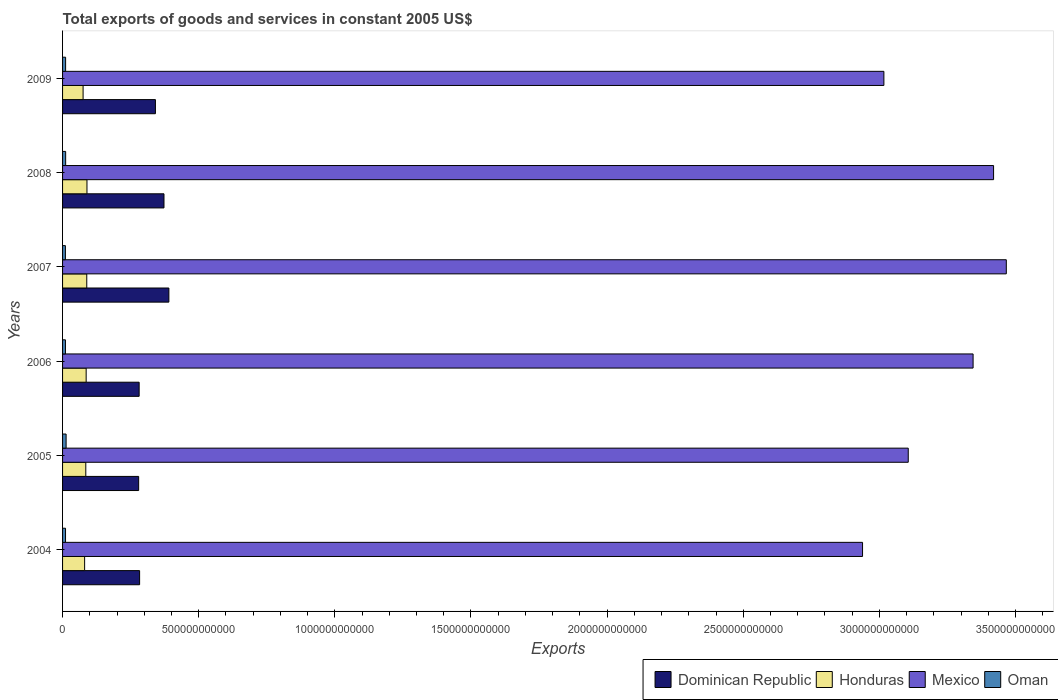Are the number of bars per tick equal to the number of legend labels?
Your answer should be compact. Yes. Are the number of bars on each tick of the Y-axis equal?
Provide a succinct answer. Yes. How many bars are there on the 4th tick from the top?
Make the answer very short. 4. In how many cases, is the number of bars for a given year not equal to the number of legend labels?
Ensure brevity in your answer.  0. What is the total exports of goods and services in Mexico in 2004?
Offer a terse response. 2.94e+12. Across all years, what is the maximum total exports of goods and services in Oman?
Your response must be concise. 1.30e+1. Across all years, what is the minimum total exports of goods and services in Mexico?
Your answer should be very brief. 2.94e+12. What is the total total exports of goods and services in Honduras in the graph?
Your response must be concise. 5.07e+11. What is the difference between the total exports of goods and services in Oman in 2005 and that in 2008?
Provide a succinct answer. 1.68e+09. What is the difference between the total exports of goods and services in Dominican Republic in 2005 and the total exports of goods and services in Oman in 2009?
Provide a succinct answer. 2.68e+11. What is the average total exports of goods and services in Oman per year?
Provide a short and direct response. 1.13e+1. In the year 2005, what is the difference between the total exports of goods and services in Oman and total exports of goods and services in Dominican Republic?
Your answer should be very brief. -2.66e+11. What is the ratio of the total exports of goods and services in Mexico in 2004 to that in 2009?
Provide a succinct answer. 0.97. Is the difference between the total exports of goods and services in Oman in 2004 and 2007 greater than the difference between the total exports of goods and services in Dominican Republic in 2004 and 2007?
Keep it short and to the point. Yes. What is the difference between the highest and the second highest total exports of goods and services in Honduras?
Offer a very short reply. 7.64e+08. What is the difference between the highest and the lowest total exports of goods and services in Honduras?
Provide a short and direct response. 1.42e+1. What does the 1st bar from the top in 2004 represents?
Make the answer very short. Oman. What does the 1st bar from the bottom in 2006 represents?
Your answer should be very brief. Dominican Republic. Is it the case that in every year, the sum of the total exports of goods and services in Oman and total exports of goods and services in Dominican Republic is greater than the total exports of goods and services in Honduras?
Offer a terse response. Yes. How many bars are there?
Make the answer very short. 24. How many years are there in the graph?
Offer a terse response. 6. What is the difference between two consecutive major ticks on the X-axis?
Ensure brevity in your answer.  5.00e+11. Are the values on the major ticks of X-axis written in scientific E-notation?
Give a very brief answer. No. How many legend labels are there?
Offer a terse response. 4. How are the legend labels stacked?
Make the answer very short. Horizontal. What is the title of the graph?
Provide a succinct answer. Total exports of goods and services in constant 2005 US$. Does "Moldova" appear as one of the legend labels in the graph?
Your answer should be compact. No. What is the label or title of the X-axis?
Your response must be concise. Exports. What is the label or title of the Y-axis?
Offer a terse response. Years. What is the Exports in Dominican Republic in 2004?
Your answer should be compact. 2.83e+11. What is the Exports in Honduras in 2004?
Ensure brevity in your answer.  8.10e+1. What is the Exports of Mexico in 2004?
Provide a succinct answer. 2.94e+12. What is the Exports of Oman in 2004?
Offer a terse response. 1.09e+1. What is the Exports in Dominican Republic in 2005?
Your answer should be compact. 2.79e+11. What is the Exports of Honduras in 2005?
Provide a short and direct response. 8.53e+1. What is the Exports in Mexico in 2005?
Your answer should be very brief. 3.11e+12. What is the Exports of Oman in 2005?
Give a very brief answer. 1.30e+1. What is the Exports of Dominican Republic in 2006?
Make the answer very short. 2.81e+11. What is the Exports of Honduras in 2006?
Ensure brevity in your answer.  8.67e+1. What is the Exports of Mexico in 2006?
Your response must be concise. 3.34e+12. What is the Exports of Oman in 2006?
Provide a short and direct response. 1.06e+1. What is the Exports of Dominican Republic in 2007?
Offer a terse response. 3.90e+11. What is the Exports of Honduras in 2007?
Give a very brief answer. 8.89e+1. What is the Exports of Mexico in 2007?
Make the answer very short. 3.47e+12. What is the Exports of Oman in 2007?
Provide a succinct answer. 1.04e+1. What is the Exports of Dominican Republic in 2008?
Your answer should be compact. 3.72e+11. What is the Exports in Honduras in 2008?
Make the answer very short. 8.96e+1. What is the Exports in Mexico in 2008?
Ensure brevity in your answer.  3.42e+12. What is the Exports in Oman in 2008?
Your response must be concise. 1.14e+1. What is the Exports in Dominican Republic in 2009?
Make the answer very short. 3.41e+11. What is the Exports of Honduras in 2009?
Offer a very short reply. 7.54e+1. What is the Exports of Mexico in 2009?
Provide a short and direct response. 3.02e+12. What is the Exports of Oman in 2009?
Provide a short and direct response. 1.12e+1. Across all years, what is the maximum Exports of Dominican Republic?
Give a very brief answer. 3.90e+11. Across all years, what is the maximum Exports in Honduras?
Offer a very short reply. 8.96e+1. Across all years, what is the maximum Exports in Mexico?
Ensure brevity in your answer.  3.47e+12. Across all years, what is the maximum Exports of Oman?
Give a very brief answer. 1.30e+1. Across all years, what is the minimum Exports of Dominican Republic?
Your answer should be compact. 2.79e+11. Across all years, what is the minimum Exports in Honduras?
Offer a very short reply. 7.54e+1. Across all years, what is the minimum Exports in Mexico?
Keep it short and to the point. 2.94e+12. Across all years, what is the minimum Exports in Oman?
Your response must be concise. 1.04e+1. What is the total Exports of Dominican Republic in the graph?
Offer a terse response. 1.95e+12. What is the total Exports of Honduras in the graph?
Offer a terse response. 5.07e+11. What is the total Exports of Mexico in the graph?
Keep it short and to the point. 1.93e+13. What is the total Exports in Oman in the graph?
Keep it short and to the point. 6.75e+1. What is the difference between the Exports of Dominican Republic in 2004 and that in 2005?
Provide a short and direct response. 3.51e+09. What is the difference between the Exports of Honduras in 2004 and that in 2005?
Your response must be concise. -4.30e+09. What is the difference between the Exports of Mexico in 2004 and that in 2005?
Your response must be concise. -1.68e+11. What is the difference between the Exports in Oman in 2004 and that in 2005?
Keep it short and to the point. -2.12e+09. What is the difference between the Exports in Dominican Republic in 2004 and that in 2006?
Provide a succinct answer. 1.68e+09. What is the difference between the Exports in Honduras in 2004 and that in 2006?
Keep it short and to the point. -5.63e+09. What is the difference between the Exports of Mexico in 2004 and that in 2006?
Offer a terse response. -4.06e+11. What is the difference between the Exports in Oman in 2004 and that in 2006?
Offer a very short reply. 3.07e+08. What is the difference between the Exports in Dominican Republic in 2004 and that in 2007?
Provide a short and direct response. -1.08e+11. What is the difference between the Exports in Honduras in 2004 and that in 2007?
Offer a very short reply. -7.82e+09. What is the difference between the Exports in Mexico in 2004 and that in 2007?
Your answer should be very brief. -5.28e+11. What is the difference between the Exports of Oman in 2004 and that in 2007?
Ensure brevity in your answer.  5.06e+08. What is the difference between the Exports of Dominican Republic in 2004 and that in 2008?
Offer a terse response. -8.95e+1. What is the difference between the Exports of Honduras in 2004 and that in 2008?
Your answer should be very brief. -8.59e+09. What is the difference between the Exports in Mexico in 2004 and that in 2008?
Provide a short and direct response. -4.81e+11. What is the difference between the Exports in Oman in 2004 and that in 2008?
Give a very brief answer. -4.43e+08. What is the difference between the Exports in Dominican Republic in 2004 and that in 2009?
Your answer should be compact. -5.81e+1. What is the difference between the Exports of Honduras in 2004 and that in 2009?
Keep it short and to the point. 5.66e+09. What is the difference between the Exports in Mexico in 2004 and that in 2009?
Provide a short and direct response. -7.84e+1. What is the difference between the Exports in Oman in 2004 and that in 2009?
Provide a short and direct response. -2.93e+08. What is the difference between the Exports of Dominican Republic in 2005 and that in 2006?
Provide a short and direct response. -1.83e+09. What is the difference between the Exports of Honduras in 2005 and that in 2006?
Your response must be concise. -1.33e+09. What is the difference between the Exports of Mexico in 2005 and that in 2006?
Offer a terse response. -2.38e+11. What is the difference between the Exports of Oman in 2005 and that in 2006?
Offer a terse response. 2.43e+09. What is the difference between the Exports of Dominican Republic in 2005 and that in 2007?
Offer a terse response. -1.11e+11. What is the difference between the Exports in Honduras in 2005 and that in 2007?
Ensure brevity in your answer.  -3.52e+09. What is the difference between the Exports in Mexico in 2005 and that in 2007?
Your answer should be compact. -3.60e+11. What is the difference between the Exports in Oman in 2005 and that in 2007?
Make the answer very short. 2.63e+09. What is the difference between the Exports of Dominican Republic in 2005 and that in 2008?
Your answer should be very brief. -9.30e+1. What is the difference between the Exports of Honduras in 2005 and that in 2008?
Offer a terse response. -4.29e+09. What is the difference between the Exports of Mexico in 2005 and that in 2008?
Your answer should be compact. -3.13e+11. What is the difference between the Exports of Oman in 2005 and that in 2008?
Your answer should be compact. 1.68e+09. What is the difference between the Exports in Dominican Republic in 2005 and that in 2009?
Make the answer very short. -6.16e+1. What is the difference between the Exports in Honduras in 2005 and that in 2009?
Give a very brief answer. 9.96e+09. What is the difference between the Exports in Mexico in 2005 and that in 2009?
Provide a short and direct response. 8.95e+1. What is the difference between the Exports in Oman in 2005 and that in 2009?
Your answer should be compact. 1.83e+09. What is the difference between the Exports of Dominican Republic in 2006 and that in 2007?
Make the answer very short. -1.09e+11. What is the difference between the Exports of Honduras in 2006 and that in 2007?
Your response must be concise. -2.20e+09. What is the difference between the Exports of Mexico in 2006 and that in 2007?
Ensure brevity in your answer.  -1.22e+11. What is the difference between the Exports in Oman in 2006 and that in 2007?
Your answer should be compact. 1.99e+08. What is the difference between the Exports in Dominican Republic in 2006 and that in 2008?
Give a very brief answer. -9.12e+1. What is the difference between the Exports in Honduras in 2006 and that in 2008?
Provide a succinct answer. -2.96e+09. What is the difference between the Exports of Mexico in 2006 and that in 2008?
Offer a very short reply. -7.52e+1. What is the difference between the Exports in Oman in 2006 and that in 2008?
Ensure brevity in your answer.  -7.51e+08. What is the difference between the Exports in Dominican Republic in 2006 and that in 2009?
Give a very brief answer. -5.97e+1. What is the difference between the Exports in Honduras in 2006 and that in 2009?
Your response must be concise. 1.13e+1. What is the difference between the Exports in Mexico in 2006 and that in 2009?
Keep it short and to the point. 3.28e+11. What is the difference between the Exports in Oman in 2006 and that in 2009?
Your response must be concise. -6.00e+08. What is the difference between the Exports in Dominican Republic in 2007 and that in 2008?
Make the answer very short. 1.80e+1. What is the difference between the Exports in Honduras in 2007 and that in 2008?
Your response must be concise. -7.64e+08. What is the difference between the Exports in Mexico in 2007 and that in 2008?
Offer a terse response. 4.67e+1. What is the difference between the Exports in Oman in 2007 and that in 2008?
Offer a terse response. -9.50e+08. What is the difference between the Exports of Dominican Republic in 2007 and that in 2009?
Ensure brevity in your answer.  4.94e+1. What is the difference between the Exports of Honduras in 2007 and that in 2009?
Give a very brief answer. 1.35e+1. What is the difference between the Exports of Mexico in 2007 and that in 2009?
Ensure brevity in your answer.  4.50e+11. What is the difference between the Exports in Oman in 2007 and that in 2009?
Offer a terse response. -7.99e+08. What is the difference between the Exports in Dominican Republic in 2008 and that in 2009?
Your answer should be compact. 3.14e+1. What is the difference between the Exports of Honduras in 2008 and that in 2009?
Ensure brevity in your answer.  1.42e+1. What is the difference between the Exports in Mexico in 2008 and that in 2009?
Provide a succinct answer. 4.03e+11. What is the difference between the Exports in Oman in 2008 and that in 2009?
Your answer should be very brief. 1.51e+08. What is the difference between the Exports in Dominican Republic in 2004 and the Exports in Honduras in 2005?
Give a very brief answer. 1.98e+11. What is the difference between the Exports of Dominican Republic in 2004 and the Exports of Mexico in 2005?
Make the answer very short. -2.82e+12. What is the difference between the Exports in Dominican Republic in 2004 and the Exports in Oman in 2005?
Your response must be concise. 2.70e+11. What is the difference between the Exports in Honduras in 2004 and the Exports in Mexico in 2005?
Give a very brief answer. -3.03e+12. What is the difference between the Exports of Honduras in 2004 and the Exports of Oman in 2005?
Your response must be concise. 6.80e+1. What is the difference between the Exports of Mexico in 2004 and the Exports of Oman in 2005?
Keep it short and to the point. 2.93e+12. What is the difference between the Exports in Dominican Republic in 2004 and the Exports in Honduras in 2006?
Make the answer very short. 1.96e+11. What is the difference between the Exports of Dominican Republic in 2004 and the Exports of Mexico in 2006?
Provide a succinct answer. -3.06e+12. What is the difference between the Exports in Dominican Republic in 2004 and the Exports in Oman in 2006?
Make the answer very short. 2.72e+11. What is the difference between the Exports of Honduras in 2004 and the Exports of Mexico in 2006?
Make the answer very short. -3.26e+12. What is the difference between the Exports of Honduras in 2004 and the Exports of Oman in 2006?
Your answer should be very brief. 7.04e+1. What is the difference between the Exports of Mexico in 2004 and the Exports of Oman in 2006?
Provide a succinct answer. 2.93e+12. What is the difference between the Exports in Dominican Republic in 2004 and the Exports in Honduras in 2007?
Make the answer very short. 1.94e+11. What is the difference between the Exports in Dominican Republic in 2004 and the Exports in Mexico in 2007?
Offer a terse response. -3.18e+12. What is the difference between the Exports of Dominican Republic in 2004 and the Exports of Oman in 2007?
Your response must be concise. 2.73e+11. What is the difference between the Exports in Honduras in 2004 and the Exports in Mexico in 2007?
Your answer should be very brief. -3.39e+12. What is the difference between the Exports in Honduras in 2004 and the Exports in Oman in 2007?
Offer a very short reply. 7.06e+1. What is the difference between the Exports in Mexico in 2004 and the Exports in Oman in 2007?
Offer a very short reply. 2.93e+12. What is the difference between the Exports in Dominican Republic in 2004 and the Exports in Honduras in 2008?
Provide a succinct answer. 1.93e+11. What is the difference between the Exports in Dominican Republic in 2004 and the Exports in Mexico in 2008?
Your response must be concise. -3.14e+12. What is the difference between the Exports in Dominican Republic in 2004 and the Exports in Oman in 2008?
Offer a terse response. 2.72e+11. What is the difference between the Exports of Honduras in 2004 and the Exports of Mexico in 2008?
Provide a succinct answer. -3.34e+12. What is the difference between the Exports in Honduras in 2004 and the Exports in Oman in 2008?
Make the answer very short. 6.97e+1. What is the difference between the Exports in Mexico in 2004 and the Exports in Oman in 2008?
Your response must be concise. 2.93e+12. What is the difference between the Exports of Dominican Republic in 2004 and the Exports of Honduras in 2009?
Provide a succinct answer. 2.08e+11. What is the difference between the Exports in Dominican Republic in 2004 and the Exports in Mexico in 2009?
Ensure brevity in your answer.  -2.73e+12. What is the difference between the Exports of Dominican Republic in 2004 and the Exports of Oman in 2009?
Provide a succinct answer. 2.72e+11. What is the difference between the Exports of Honduras in 2004 and the Exports of Mexico in 2009?
Make the answer very short. -2.94e+12. What is the difference between the Exports in Honduras in 2004 and the Exports in Oman in 2009?
Your answer should be very brief. 6.98e+1. What is the difference between the Exports of Mexico in 2004 and the Exports of Oman in 2009?
Offer a terse response. 2.93e+12. What is the difference between the Exports in Dominican Republic in 2005 and the Exports in Honduras in 2006?
Offer a very short reply. 1.93e+11. What is the difference between the Exports in Dominican Republic in 2005 and the Exports in Mexico in 2006?
Your answer should be compact. -3.06e+12. What is the difference between the Exports in Dominican Republic in 2005 and the Exports in Oman in 2006?
Your response must be concise. 2.69e+11. What is the difference between the Exports in Honduras in 2005 and the Exports in Mexico in 2006?
Give a very brief answer. -3.26e+12. What is the difference between the Exports of Honduras in 2005 and the Exports of Oman in 2006?
Provide a short and direct response. 7.47e+1. What is the difference between the Exports of Mexico in 2005 and the Exports of Oman in 2006?
Give a very brief answer. 3.10e+12. What is the difference between the Exports in Dominican Republic in 2005 and the Exports in Honduras in 2007?
Ensure brevity in your answer.  1.91e+11. What is the difference between the Exports in Dominican Republic in 2005 and the Exports in Mexico in 2007?
Give a very brief answer. -3.19e+12. What is the difference between the Exports of Dominican Republic in 2005 and the Exports of Oman in 2007?
Offer a very short reply. 2.69e+11. What is the difference between the Exports of Honduras in 2005 and the Exports of Mexico in 2007?
Offer a very short reply. -3.38e+12. What is the difference between the Exports in Honduras in 2005 and the Exports in Oman in 2007?
Give a very brief answer. 7.49e+1. What is the difference between the Exports in Mexico in 2005 and the Exports in Oman in 2007?
Your response must be concise. 3.10e+12. What is the difference between the Exports of Dominican Republic in 2005 and the Exports of Honduras in 2008?
Keep it short and to the point. 1.90e+11. What is the difference between the Exports of Dominican Republic in 2005 and the Exports of Mexico in 2008?
Ensure brevity in your answer.  -3.14e+12. What is the difference between the Exports in Dominican Republic in 2005 and the Exports in Oman in 2008?
Offer a very short reply. 2.68e+11. What is the difference between the Exports of Honduras in 2005 and the Exports of Mexico in 2008?
Make the answer very short. -3.33e+12. What is the difference between the Exports in Honduras in 2005 and the Exports in Oman in 2008?
Ensure brevity in your answer.  7.40e+1. What is the difference between the Exports in Mexico in 2005 and the Exports in Oman in 2008?
Ensure brevity in your answer.  3.09e+12. What is the difference between the Exports of Dominican Republic in 2005 and the Exports of Honduras in 2009?
Ensure brevity in your answer.  2.04e+11. What is the difference between the Exports in Dominican Republic in 2005 and the Exports in Mexico in 2009?
Make the answer very short. -2.74e+12. What is the difference between the Exports in Dominican Republic in 2005 and the Exports in Oman in 2009?
Give a very brief answer. 2.68e+11. What is the difference between the Exports in Honduras in 2005 and the Exports in Mexico in 2009?
Your answer should be compact. -2.93e+12. What is the difference between the Exports of Honduras in 2005 and the Exports of Oman in 2009?
Keep it short and to the point. 7.41e+1. What is the difference between the Exports in Mexico in 2005 and the Exports in Oman in 2009?
Offer a very short reply. 3.09e+12. What is the difference between the Exports of Dominican Republic in 2006 and the Exports of Honduras in 2007?
Your answer should be very brief. 1.92e+11. What is the difference between the Exports of Dominican Republic in 2006 and the Exports of Mexico in 2007?
Offer a terse response. -3.18e+12. What is the difference between the Exports of Dominican Republic in 2006 and the Exports of Oman in 2007?
Offer a very short reply. 2.71e+11. What is the difference between the Exports in Honduras in 2006 and the Exports in Mexico in 2007?
Give a very brief answer. -3.38e+12. What is the difference between the Exports in Honduras in 2006 and the Exports in Oman in 2007?
Your answer should be very brief. 7.62e+1. What is the difference between the Exports of Mexico in 2006 and the Exports of Oman in 2007?
Ensure brevity in your answer.  3.33e+12. What is the difference between the Exports of Dominican Republic in 2006 and the Exports of Honduras in 2008?
Make the answer very short. 1.92e+11. What is the difference between the Exports in Dominican Republic in 2006 and the Exports in Mexico in 2008?
Make the answer very short. -3.14e+12. What is the difference between the Exports of Dominican Republic in 2006 and the Exports of Oman in 2008?
Your answer should be very brief. 2.70e+11. What is the difference between the Exports in Honduras in 2006 and the Exports in Mexico in 2008?
Your response must be concise. -3.33e+12. What is the difference between the Exports in Honduras in 2006 and the Exports in Oman in 2008?
Your response must be concise. 7.53e+1. What is the difference between the Exports of Mexico in 2006 and the Exports of Oman in 2008?
Your answer should be very brief. 3.33e+12. What is the difference between the Exports of Dominican Republic in 2006 and the Exports of Honduras in 2009?
Provide a short and direct response. 2.06e+11. What is the difference between the Exports in Dominican Republic in 2006 and the Exports in Mexico in 2009?
Provide a succinct answer. -2.74e+12. What is the difference between the Exports in Dominican Republic in 2006 and the Exports in Oman in 2009?
Your response must be concise. 2.70e+11. What is the difference between the Exports in Honduras in 2006 and the Exports in Mexico in 2009?
Give a very brief answer. -2.93e+12. What is the difference between the Exports of Honduras in 2006 and the Exports of Oman in 2009?
Keep it short and to the point. 7.55e+1. What is the difference between the Exports in Mexico in 2006 and the Exports in Oman in 2009?
Offer a terse response. 3.33e+12. What is the difference between the Exports in Dominican Republic in 2007 and the Exports in Honduras in 2008?
Provide a short and direct response. 3.01e+11. What is the difference between the Exports in Dominican Republic in 2007 and the Exports in Mexico in 2008?
Give a very brief answer. -3.03e+12. What is the difference between the Exports of Dominican Republic in 2007 and the Exports of Oman in 2008?
Provide a succinct answer. 3.79e+11. What is the difference between the Exports of Honduras in 2007 and the Exports of Mexico in 2008?
Your answer should be compact. -3.33e+12. What is the difference between the Exports in Honduras in 2007 and the Exports in Oman in 2008?
Provide a succinct answer. 7.75e+1. What is the difference between the Exports of Mexico in 2007 and the Exports of Oman in 2008?
Ensure brevity in your answer.  3.45e+12. What is the difference between the Exports of Dominican Republic in 2007 and the Exports of Honduras in 2009?
Your answer should be compact. 3.15e+11. What is the difference between the Exports of Dominican Republic in 2007 and the Exports of Mexico in 2009?
Provide a succinct answer. -2.63e+12. What is the difference between the Exports of Dominican Republic in 2007 and the Exports of Oman in 2009?
Your answer should be compact. 3.79e+11. What is the difference between the Exports in Honduras in 2007 and the Exports in Mexico in 2009?
Your answer should be very brief. -2.93e+12. What is the difference between the Exports of Honduras in 2007 and the Exports of Oman in 2009?
Your response must be concise. 7.76e+1. What is the difference between the Exports of Mexico in 2007 and the Exports of Oman in 2009?
Give a very brief answer. 3.45e+12. What is the difference between the Exports of Dominican Republic in 2008 and the Exports of Honduras in 2009?
Ensure brevity in your answer.  2.97e+11. What is the difference between the Exports in Dominican Republic in 2008 and the Exports in Mexico in 2009?
Provide a succinct answer. -2.64e+12. What is the difference between the Exports of Dominican Republic in 2008 and the Exports of Oman in 2009?
Ensure brevity in your answer.  3.61e+11. What is the difference between the Exports of Honduras in 2008 and the Exports of Mexico in 2009?
Your answer should be compact. -2.93e+12. What is the difference between the Exports of Honduras in 2008 and the Exports of Oman in 2009?
Provide a short and direct response. 7.84e+1. What is the difference between the Exports of Mexico in 2008 and the Exports of Oman in 2009?
Offer a very short reply. 3.41e+12. What is the average Exports of Dominican Republic per year?
Make the answer very short. 3.25e+11. What is the average Exports of Honduras per year?
Ensure brevity in your answer.  8.45e+1. What is the average Exports in Mexico per year?
Keep it short and to the point. 3.22e+12. What is the average Exports of Oman per year?
Your answer should be very brief. 1.13e+1. In the year 2004, what is the difference between the Exports in Dominican Republic and Exports in Honduras?
Provide a succinct answer. 2.02e+11. In the year 2004, what is the difference between the Exports in Dominican Republic and Exports in Mexico?
Keep it short and to the point. -2.66e+12. In the year 2004, what is the difference between the Exports of Dominican Republic and Exports of Oman?
Keep it short and to the point. 2.72e+11. In the year 2004, what is the difference between the Exports of Honduras and Exports of Mexico?
Give a very brief answer. -2.86e+12. In the year 2004, what is the difference between the Exports in Honduras and Exports in Oman?
Keep it short and to the point. 7.01e+1. In the year 2004, what is the difference between the Exports in Mexico and Exports in Oman?
Your answer should be compact. 2.93e+12. In the year 2005, what is the difference between the Exports in Dominican Republic and Exports in Honduras?
Make the answer very short. 1.94e+11. In the year 2005, what is the difference between the Exports of Dominican Republic and Exports of Mexico?
Your answer should be very brief. -2.83e+12. In the year 2005, what is the difference between the Exports of Dominican Republic and Exports of Oman?
Provide a succinct answer. 2.66e+11. In the year 2005, what is the difference between the Exports in Honduras and Exports in Mexico?
Keep it short and to the point. -3.02e+12. In the year 2005, what is the difference between the Exports of Honduras and Exports of Oman?
Keep it short and to the point. 7.23e+1. In the year 2005, what is the difference between the Exports of Mexico and Exports of Oman?
Provide a short and direct response. 3.09e+12. In the year 2006, what is the difference between the Exports in Dominican Republic and Exports in Honduras?
Your answer should be compact. 1.95e+11. In the year 2006, what is the difference between the Exports of Dominican Republic and Exports of Mexico?
Make the answer very short. -3.06e+12. In the year 2006, what is the difference between the Exports of Dominican Republic and Exports of Oman?
Make the answer very short. 2.71e+11. In the year 2006, what is the difference between the Exports of Honduras and Exports of Mexico?
Provide a short and direct response. -3.26e+12. In the year 2006, what is the difference between the Exports in Honduras and Exports in Oman?
Your response must be concise. 7.61e+1. In the year 2006, what is the difference between the Exports in Mexico and Exports in Oman?
Give a very brief answer. 3.33e+12. In the year 2007, what is the difference between the Exports in Dominican Republic and Exports in Honduras?
Provide a short and direct response. 3.02e+11. In the year 2007, what is the difference between the Exports in Dominican Republic and Exports in Mexico?
Your answer should be very brief. -3.08e+12. In the year 2007, what is the difference between the Exports in Dominican Republic and Exports in Oman?
Provide a succinct answer. 3.80e+11. In the year 2007, what is the difference between the Exports in Honduras and Exports in Mexico?
Your answer should be very brief. -3.38e+12. In the year 2007, what is the difference between the Exports in Honduras and Exports in Oman?
Your answer should be very brief. 7.84e+1. In the year 2007, what is the difference between the Exports in Mexico and Exports in Oman?
Make the answer very short. 3.46e+12. In the year 2008, what is the difference between the Exports of Dominican Republic and Exports of Honduras?
Ensure brevity in your answer.  2.83e+11. In the year 2008, what is the difference between the Exports of Dominican Republic and Exports of Mexico?
Your response must be concise. -3.05e+12. In the year 2008, what is the difference between the Exports of Dominican Republic and Exports of Oman?
Give a very brief answer. 3.61e+11. In the year 2008, what is the difference between the Exports in Honduras and Exports in Mexico?
Your answer should be compact. -3.33e+12. In the year 2008, what is the difference between the Exports in Honduras and Exports in Oman?
Keep it short and to the point. 7.83e+1. In the year 2008, what is the difference between the Exports in Mexico and Exports in Oman?
Provide a succinct answer. 3.41e+12. In the year 2009, what is the difference between the Exports of Dominican Republic and Exports of Honduras?
Your response must be concise. 2.66e+11. In the year 2009, what is the difference between the Exports of Dominican Republic and Exports of Mexico?
Your answer should be compact. -2.68e+12. In the year 2009, what is the difference between the Exports in Dominican Republic and Exports in Oman?
Provide a short and direct response. 3.30e+11. In the year 2009, what is the difference between the Exports of Honduras and Exports of Mexico?
Keep it short and to the point. -2.94e+12. In the year 2009, what is the difference between the Exports of Honduras and Exports of Oman?
Your response must be concise. 6.42e+1. In the year 2009, what is the difference between the Exports in Mexico and Exports in Oman?
Make the answer very short. 3.01e+12. What is the ratio of the Exports in Dominican Republic in 2004 to that in 2005?
Offer a terse response. 1.01. What is the ratio of the Exports of Honduras in 2004 to that in 2005?
Provide a short and direct response. 0.95. What is the ratio of the Exports of Mexico in 2004 to that in 2005?
Make the answer very short. 0.95. What is the ratio of the Exports of Oman in 2004 to that in 2005?
Provide a short and direct response. 0.84. What is the ratio of the Exports of Honduras in 2004 to that in 2006?
Make the answer very short. 0.94. What is the ratio of the Exports of Mexico in 2004 to that in 2006?
Provide a succinct answer. 0.88. What is the ratio of the Exports in Oman in 2004 to that in 2006?
Provide a succinct answer. 1.03. What is the ratio of the Exports in Dominican Republic in 2004 to that in 2007?
Give a very brief answer. 0.72. What is the ratio of the Exports in Honduras in 2004 to that in 2007?
Your answer should be very brief. 0.91. What is the ratio of the Exports of Mexico in 2004 to that in 2007?
Offer a very short reply. 0.85. What is the ratio of the Exports in Oman in 2004 to that in 2007?
Provide a succinct answer. 1.05. What is the ratio of the Exports of Dominican Republic in 2004 to that in 2008?
Offer a terse response. 0.76. What is the ratio of the Exports in Honduras in 2004 to that in 2008?
Your answer should be compact. 0.9. What is the ratio of the Exports in Mexico in 2004 to that in 2008?
Provide a succinct answer. 0.86. What is the ratio of the Exports of Dominican Republic in 2004 to that in 2009?
Provide a succinct answer. 0.83. What is the ratio of the Exports of Honduras in 2004 to that in 2009?
Offer a terse response. 1.08. What is the ratio of the Exports in Oman in 2004 to that in 2009?
Offer a very short reply. 0.97. What is the ratio of the Exports of Honduras in 2005 to that in 2006?
Offer a terse response. 0.98. What is the ratio of the Exports in Mexico in 2005 to that in 2006?
Your answer should be compact. 0.93. What is the ratio of the Exports in Oman in 2005 to that in 2006?
Your answer should be compact. 1.23. What is the ratio of the Exports of Dominican Republic in 2005 to that in 2007?
Your answer should be compact. 0.72. What is the ratio of the Exports in Honduras in 2005 to that in 2007?
Ensure brevity in your answer.  0.96. What is the ratio of the Exports of Mexico in 2005 to that in 2007?
Make the answer very short. 0.9. What is the ratio of the Exports in Oman in 2005 to that in 2007?
Give a very brief answer. 1.25. What is the ratio of the Exports in Dominican Republic in 2005 to that in 2008?
Your answer should be compact. 0.75. What is the ratio of the Exports of Honduras in 2005 to that in 2008?
Offer a very short reply. 0.95. What is the ratio of the Exports in Mexico in 2005 to that in 2008?
Offer a terse response. 0.91. What is the ratio of the Exports in Oman in 2005 to that in 2008?
Your answer should be very brief. 1.15. What is the ratio of the Exports in Dominican Republic in 2005 to that in 2009?
Make the answer very short. 0.82. What is the ratio of the Exports of Honduras in 2005 to that in 2009?
Provide a succinct answer. 1.13. What is the ratio of the Exports in Mexico in 2005 to that in 2009?
Provide a succinct answer. 1.03. What is the ratio of the Exports of Oman in 2005 to that in 2009?
Give a very brief answer. 1.16. What is the ratio of the Exports of Dominican Republic in 2006 to that in 2007?
Ensure brevity in your answer.  0.72. What is the ratio of the Exports in Honduras in 2006 to that in 2007?
Keep it short and to the point. 0.98. What is the ratio of the Exports of Mexico in 2006 to that in 2007?
Your answer should be compact. 0.96. What is the ratio of the Exports of Oman in 2006 to that in 2007?
Offer a very short reply. 1.02. What is the ratio of the Exports of Dominican Republic in 2006 to that in 2008?
Provide a short and direct response. 0.76. What is the ratio of the Exports of Honduras in 2006 to that in 2008?
Provide a short and direct response. 0.97. What is the ratio of the Exports of Mexico in 2006 to that in 2008?
Your response must be concise. 0.98. What is the ratio of the Exports of Oman in 2006 to that in 2008?
Ensure brevity in your answer.  0.93. What is the ratio of the Exports in Dominican Republic in 2006 to that in 2009?
Provide a short and direct response. 0.82. What is the ratio of the Exports in Honduras in 2006 to that in 2009?
Your response must be concise. 1.15. What is the ratio of the Exports of Mexico in 2006 to that in 2009?
Offer a very short reply. 1.11. What is the ratio of the Exports of Oman in 2006 to that in 2009?
Provide a succinct answer. 0.95. What is the ratio of the Exports of Dominican Republic in 2007 to that in 2008?
Your answer should be compact. 1.05. What is the ratio of the Exports in Honduras in 2007 to that in 2008?
Provide a succinct answer. 0.99. What is the ratio of the Exports in Mexico in 2007 to that in 2008?
Your answer should be very brief. 1.01. What is the ratio of the Exports in Oman in 2007 to that in 2008?
Provide a succinct answer. 0.92. What is the ratio of the Exports of Dominican Republic in 2007 to that in 2009?
Your answer should be compact. 1.15. What is the ratio of the Exports in Honduras in 2007 to that in 2009?
Your answer should be very brief. 1.18. What is the ratio of the Exports of Mexico in 2007 to that in 2009?
Offer a terse response. 1.15. What is the ratio of the Exports in Oman in 2007 to that in 2009?
Give a very brief answer. 0.93. What is the ratio of the Exports of Dominican Republic in 2008 to that in 2009?
Offer a very short reply. 1.09. What is the ratio of the Exports of Honduras in 2008 to that in 2009?
Make the answer very short. 1.19. What is the ratio of the Exports in Mexico in 2008 to that in 2009?
Offer a terse response. 1.13. What is the ratio of the Exports of Oman in 2008 to that in 2009?
Your response must be concise. 1.01. What is the difference between the highest and the second highest Exports in Dominican Republic?
Your answer should be very brief. 1.80e+1. What is the difference between the highest and the second highest Exports in Honduras?
Provide a short and direct response. 7.64e+08. What is the difference between the highest and the second highest Exports in Mexico?
Your answer should be very brief. 4.67e+1. What is the difference between the highest and the second highest Exports in Oman?
Offer a terse response. 1.68e+09. What is the difference between the highest and the lowest Exports of Dominican Republic?
Provide a short and direct response. 1.11e+11. What is the difference between the highest and the lowest Exports of Honduras?
Offer a very short reply. 1.42e+1. What is the difference between the highest and the lowest Exports of Mexico?
Your answer should be compact. 5.28e+11. What is the difference between the highest and the lowest Exports of Oman?
Offer a terse response. 2.63e+09. 